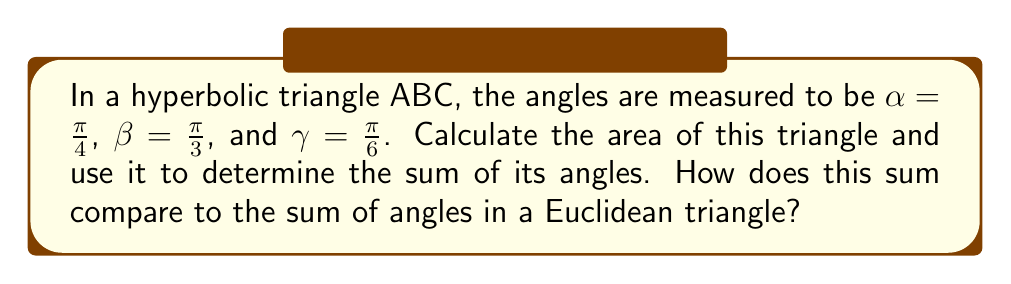Give your solution to this math problem. Let's approach this step-by-step:

1) In hyperbolic geometry, the area of a triangle is given by the formula:

   $$A = \pi - (\alpha + \beta + \gamma)$$

   Where $A$ is the area and $\alpha$, $\beta$, $\gamma$ are the angles of the triangle.

2) We're given:
   $\alpha = \frac{\pi}{4}$
   $\beta = \frac{\pi}{3}$
   $\gamma = \frac{\pi}{6}$

3) Let's substitute these into our area formula:

   $$A = \pi - (\frac{\pi}{4} + \frac{\pi}{3} + \frac{\pi}{6})$$

4) Simplify the fraction in parentheses:
   
   $$A = \pi - (\frac{3\pi}{12} + \frac{4\pi}{12} + \frac{2\pi}{12})$$
   $$A = \pi - \frac{9\pi}{12}$$

5) Subtract:

   $$A = \frac{12\pi}{12} - \frac{9\pi}{12} = \frac{3\pi}{12} = \frac{\pi}{4}$$

6) Now, to find the sum of the angles, we can rearrange our area formula:

   $$\alpha + \beta + \gamma = \pi - A$$

7) Substitute our calculated area:

   $$\alpha + \beta + \gamma = \pi - \frac{\pi}{4} = \frac{3\pi}{4}$$

8) In radians, this is equivalent to 135°.

9) In a Euclidean triangle, the sum of angles is always $\pi$ radians or 180°.

Therefore, the sum of angles in this hyperbolic triangle ($\frac{3\pi}{4}$ or 135°) is less than the sum of angles in a Euclidean triangle ($\pi$ or 180°).
Answer: $\frac{3\pi}{4}$ radians (135°), which is less than $\pi$ radians (180°) in Euclidean geometry. 